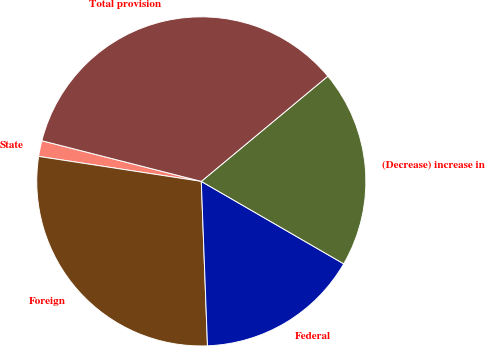Convert chart. <chart><loc_0><loc_0><loc_500><loc_500><pie_chart><fcel>State<fcel>Foreign<fcel>Federal<fcel>(Decrease) increase in<fcel>Total provision<nl><fcel>1.55%<fcel>28.02%<fcel>16.05%<fcel>19.39%<fcel>34.98%<nl></chart> 